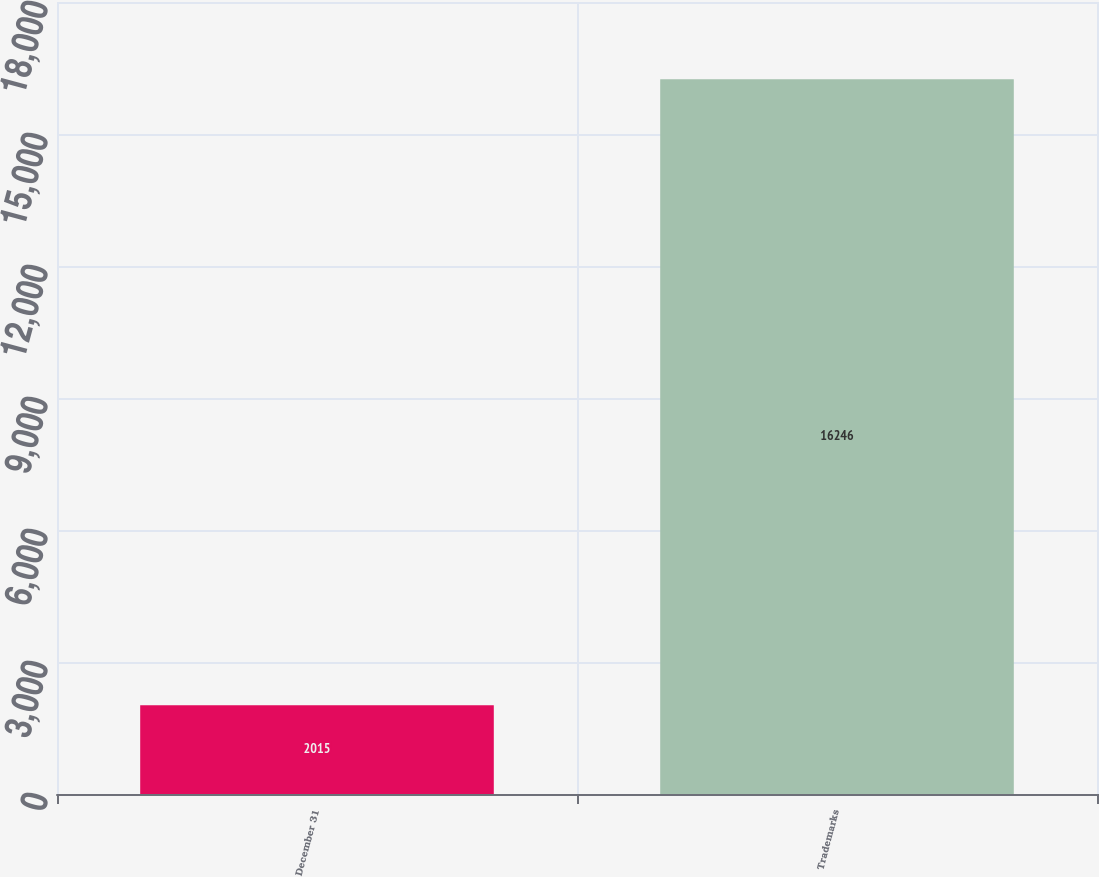Convert chart to OTSL. <chart><loc_0><loc_0><loc_500><loc_500><bar_chart><fcel>December 31<fcel>Trademarks<nl><fcel>2015<fcel>16246<nl></chart> 